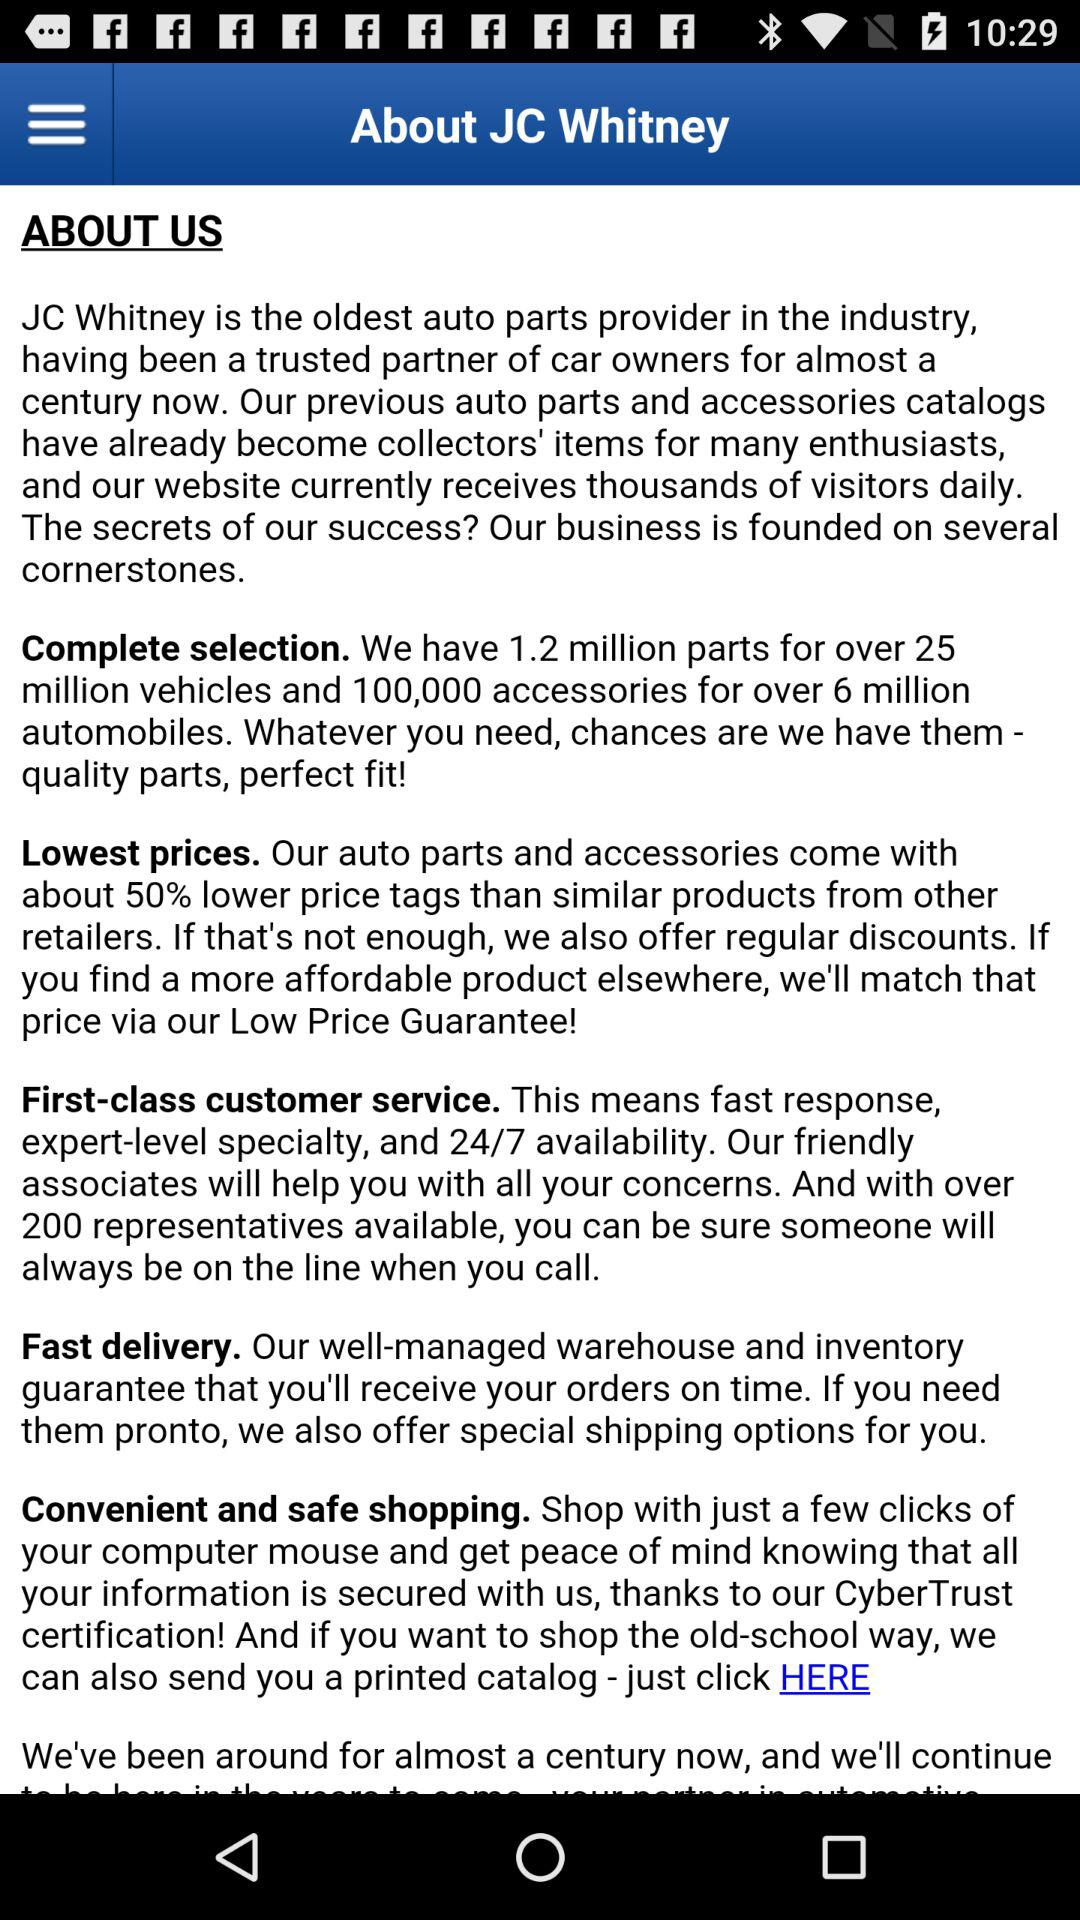What percentage discount is given on auto parts prices? The percentage is about 50. 